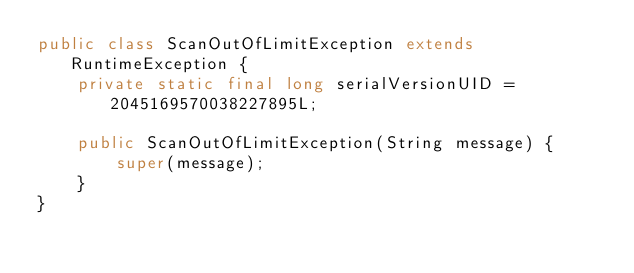Convert code to text. <code><loc_0><loc_0><loc_500><loc_500><_Java_>public class ScanOutOfLimitException extends RuntimeException {
    private static final long serialVersionUID = 2045169570038227895L;

    public ScanOutOfLimitException(String message) {
        super(message);
    }
}
</code> 